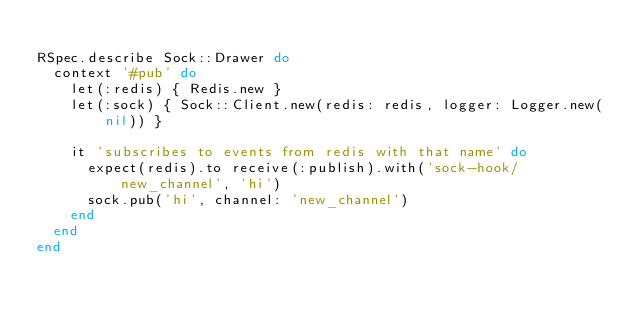Convert code to text. <code><loc_0><loc_0><loc_500><loc_500><_Ruby_>
RSpec.describe Sock::Drawer do
  context '#pub' do
    let(:redis) { Redis.new }
    let(:sock) { Sock::Client.new(redis: redis, logger: Logger.new(nil)) }

    it 'subscribes to events from redis with that name' do
      expect(redis).to receive(:publish).with('sock-hook/new_channel', 'hi')
      sock.pub('hi', channel: 'new_channel')
    end
  end
end
</code> 